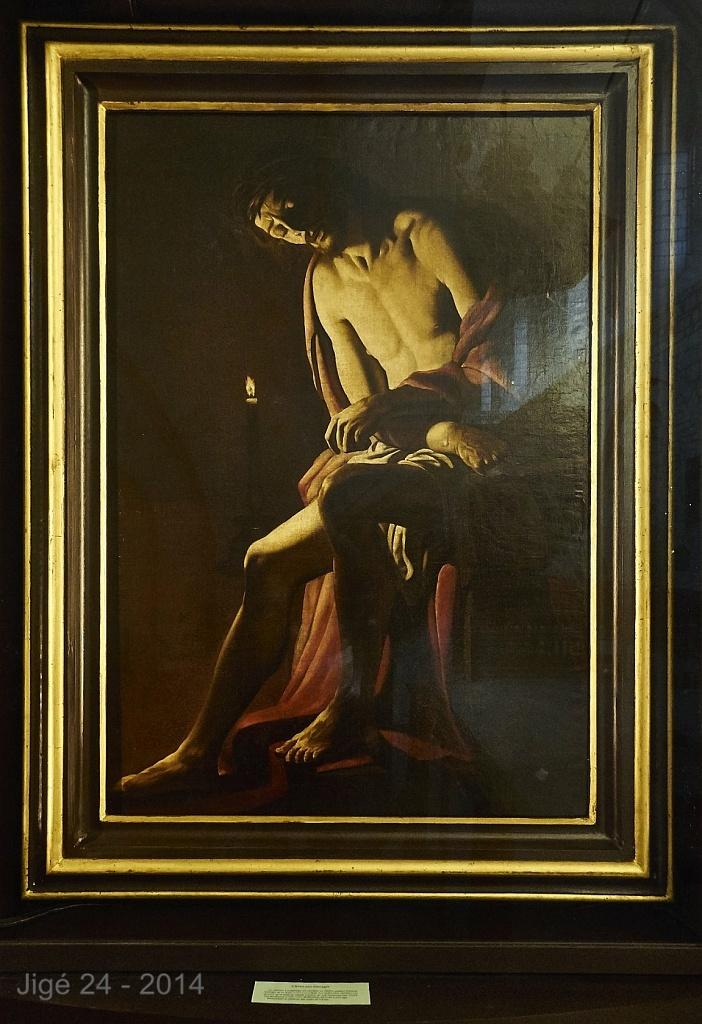What number is next to the year in the corner?
Ensure brevity in your answer.  24. What year is on the bottom left?
Provide a succinct answer. 2014. 